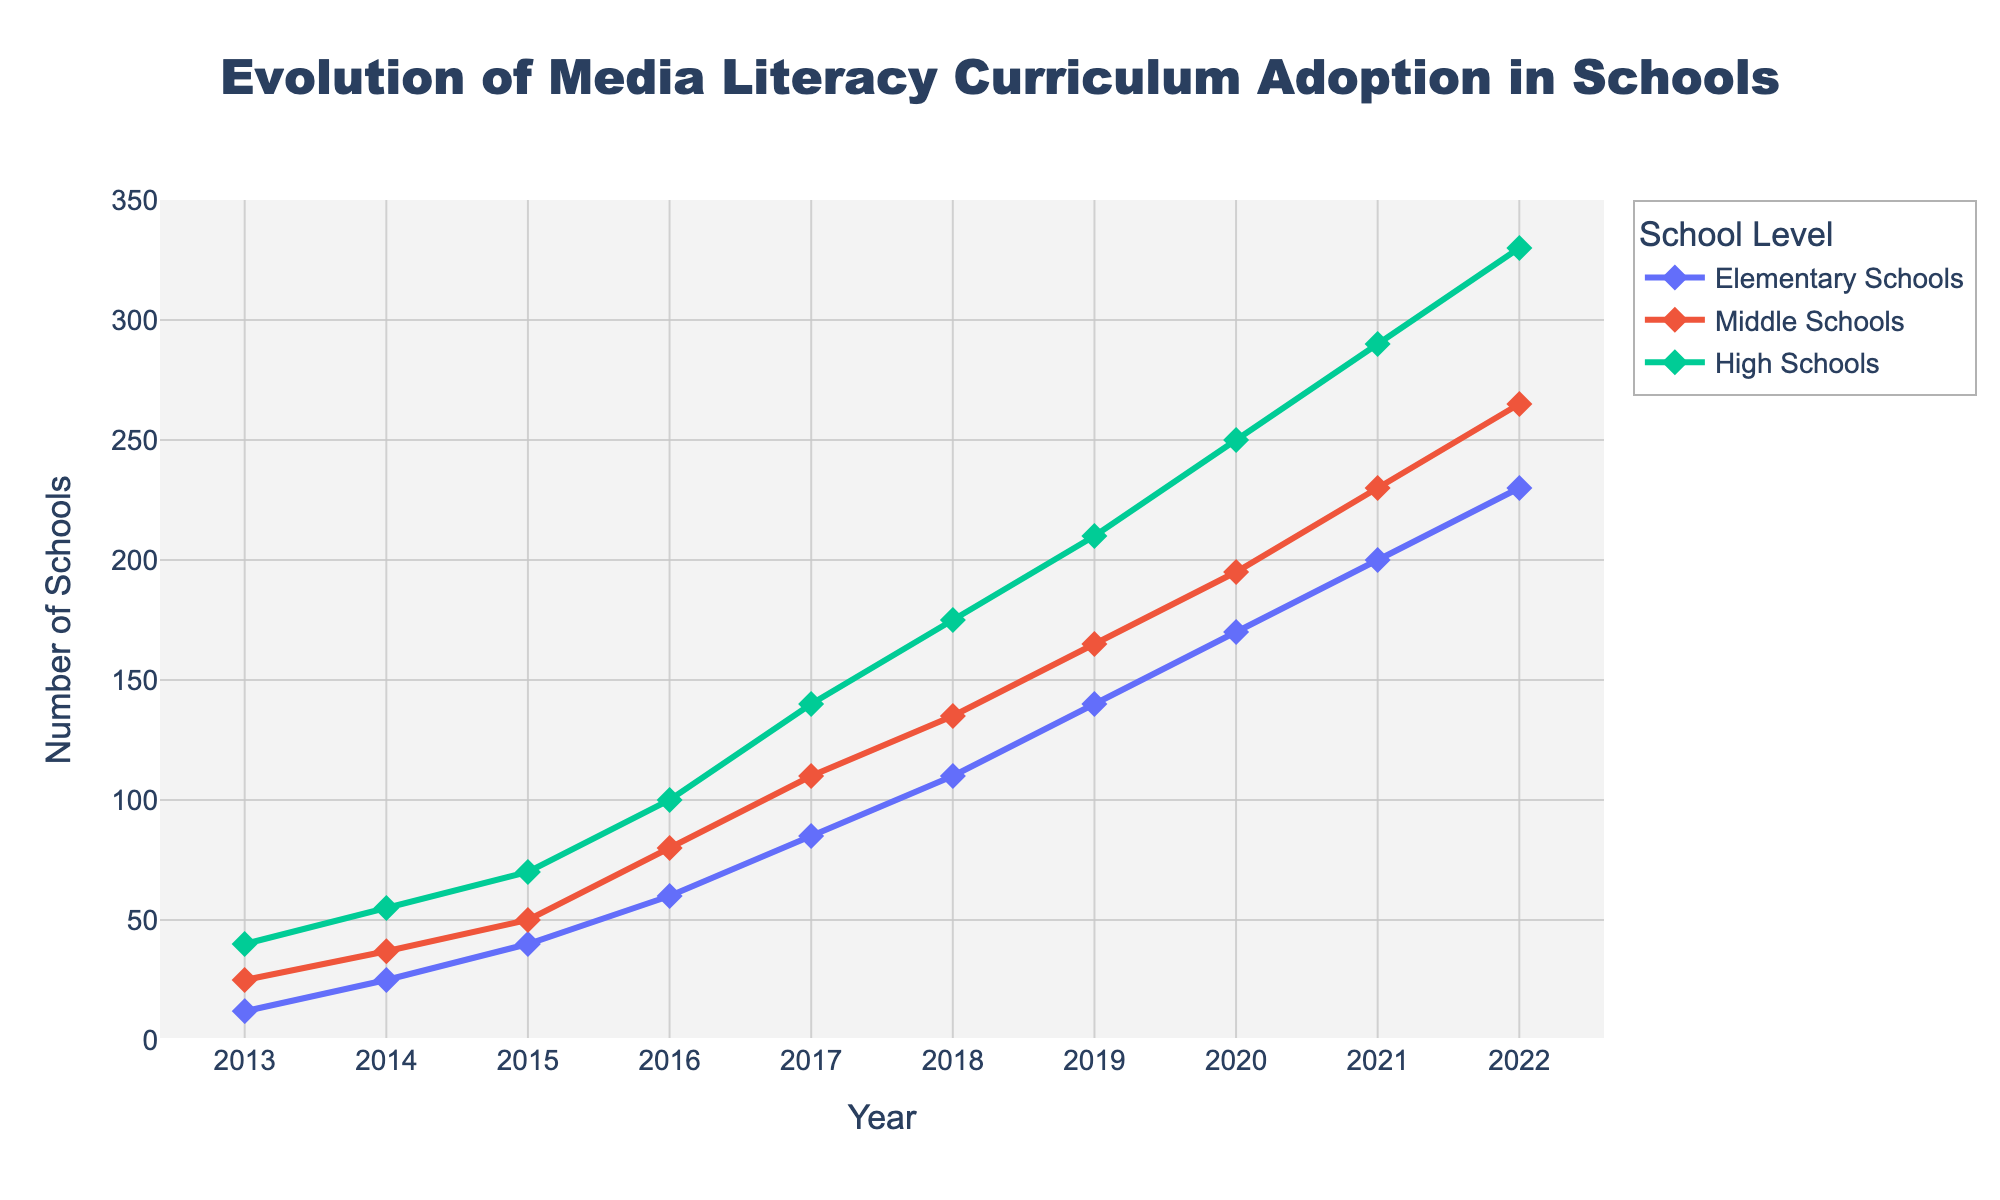What's the title of the plot? The title is displayed at the top center of the plot.
Answer: Evolution of Media Literacy Curriculum Adoption in Schools What year does the plot start from? The x-axis represents the years, starting with the earliest year on the left.
Answer: 2013 What's the highest value for High Schools, and in what year does it occur? On the y-axis under "High Schools," the line reaches its highest point in the final year on the right.
Answer: 330 in 2022 Between which years did Elementary Schools see the largest increase in adoption? The vertical distance between points in consecutive years shows the increase. The steepest slope between two points on the Elementary Schools line shows the largest increase.
Answer: 2015 to 2016 In 2020, how many schools in total adopted media literacy curriculum? For each school level, use the y-values in 2020 and sum them: 170 (Elementary) + 195 (Middle) + 250 (High).
Answer: 615 Which school level had the fastest increase in curriculum adoption during the decade? Observe the slope of each school's line; the line that rises the steepest overall indicates the fastest increase.
Answer: Elementary Schools How many years does it take for the number of High Schools to reach 100? Follow the High Schools line from the starting point until it first reaches 100 on the y-axis.
Answer: 2016 In 2018, how much higher is the adoption rate in Middle Schools compared to Elementary Schools? Subtract the number for Elementary Schools from Middle Schools in 2018: 135 (Middle) - 110 (Elementary).
Answer: 25 Which school level had the smallest number of adoptions in any given year, and what was that number? Look at the lowest points on each of the three lines.
Answer: Elementary Schools, 12 in 2013 What's the average number of schools adopting the curriculum in Middle Schools over the ten years? Add up all the values for Middle Schools and divide by the number of years: (25 + 37 + 50 + 80 + 110 + 135 + 165 + 195 + 230 + 265) / 10.
Answer: 129 